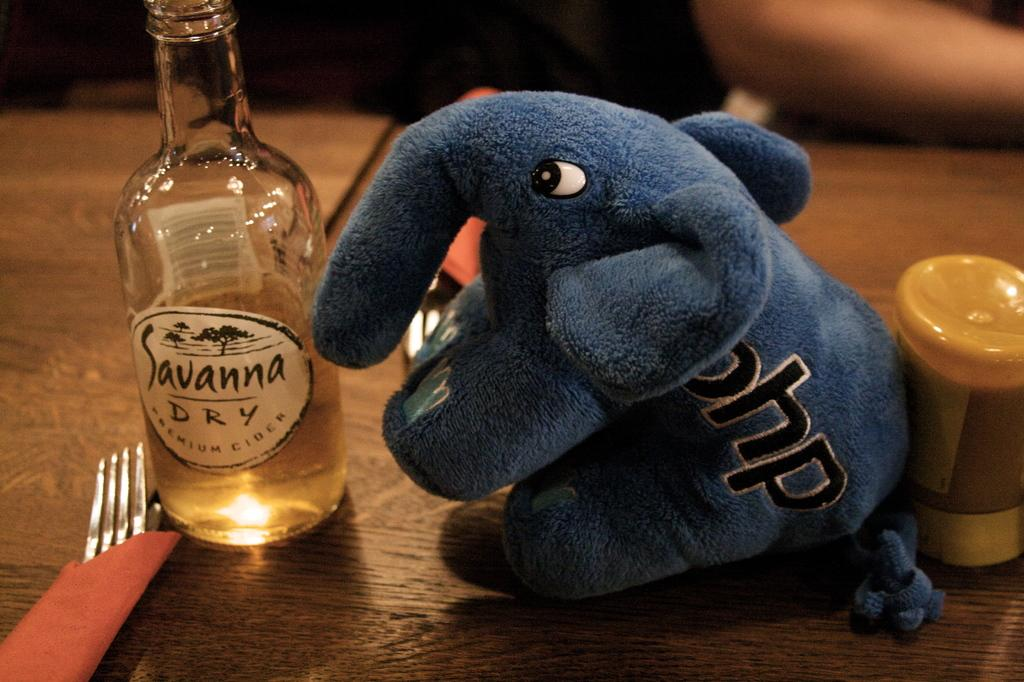What can be seen in the background of the image? There is a human's hand in the background of the image. What objects are present on the table in the image? There is a bottle, an elephant doll, a container, and a fork on the table. What time is displayed on the hourglass in the image? There is no hourglass present in the image. What type of transportation is shown in the image? There is no transportation depicted in the image. 